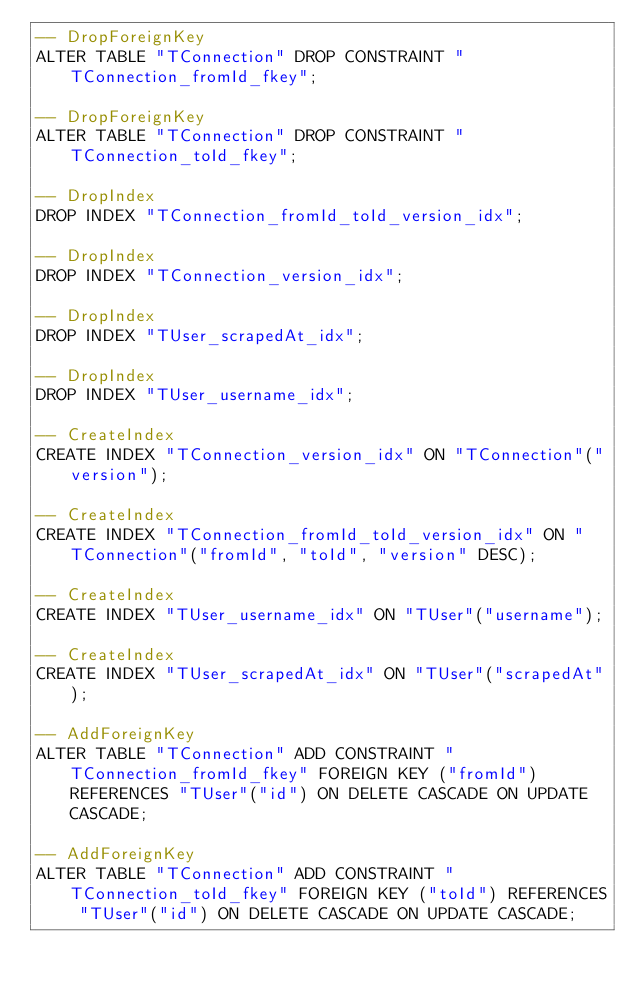Convert code to text. <code><loc_0><loc_0><loc_500><loc_500><_SQL_>-- DropForeignKey
ALTER TABLE "TConnection" DROP CONSTRAINT "TConnection_fromId_fkey";

-- DropForeignKey
ALTER TABLE "TConnection" DROP CONSTRAINT "TConnection_toId_fkey";

-- DropIndex
DROP INDEX "TConnection_fromId_toId_version_idx";

-- DropIndex
DROP INDEX "TConnection_version_idx";

-- DropIndex
DROP INDEX "TUser_scrapedAt_idx";

-- DropIndex
DROP INDEX "TUser_username_idx";

-- CreateIndex
CREATE INDEX "TConnection_version_idx" ON "TConnection"("version");

-- CreateIndex
CREATE INDEX "TConnection_fromId_toId_version_idx" ON "TConnection"("fromId", "toId", "version" DESC);

-- CreateIndex
CREATE INDEX "TUser_username_idx" ON "TUser"("username");

-- CreateIndex
CREATE INDEX "TUser_scrapedAt_idx" ON "TUser"("scrapedAt");

-- AddForeignKey
ALTER TABLE "TConnection" ADD CONSTRAINT "TConnection_fromId_fkey" FOREIGN KEY ("fromId") REFERENCES "TUser"("id") ON DELETE CASCADE ON UPDATE CASCADE;

-- AddForeignKey
ALTER TABLE "TConnection" ADD CONSTRAINT "TConnection_toId_fkey" FOREIGN KEY ("toId") REFERENCES "TUser"("id") ON DELETE CASCADE ON UPDATE CASCADE;
</code> 